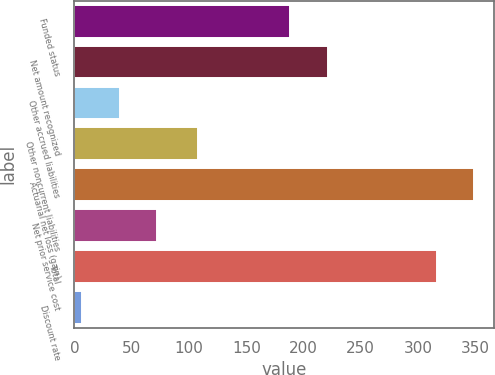Convert chart to OTSL. <chart><loc_0><loc_0><loc_500><loc_500><bar_chart><fcel>Funded status<fcel>Net amount recognized<fcel>Other accrued liabilities<fcel>Other noncurrent liabilities<fcel>Actuarial net loss (gain)<fcel>Net prior service cost<fcel>Total<fcel>Discount rate<nl><fcel>188.3<fcel>221.06<fcel>39.36<fcel>107.5<fcel>349.26<fcel>72.12<fcel>316.5<fcel>6.6<nl></chart> 